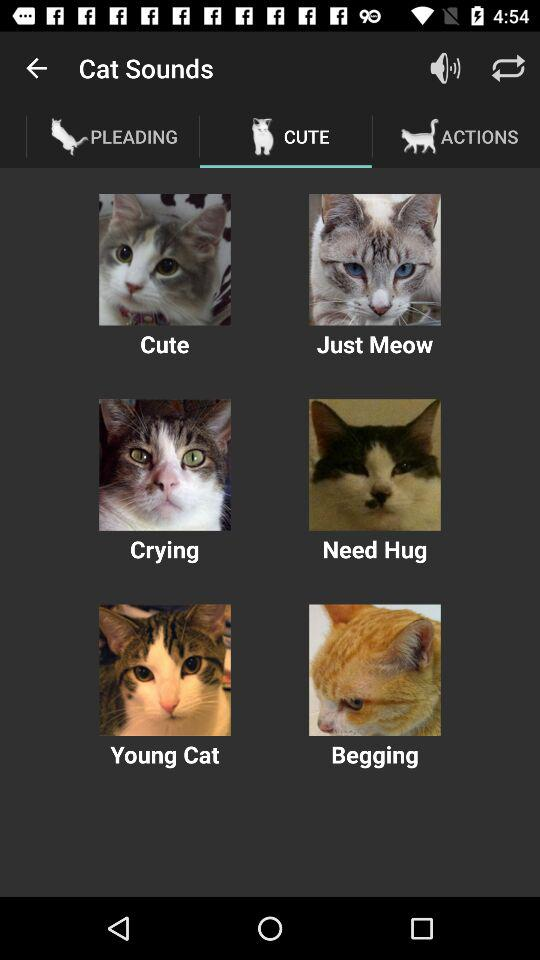What is the name of the application? The name of the application is "Cat Sounds". 